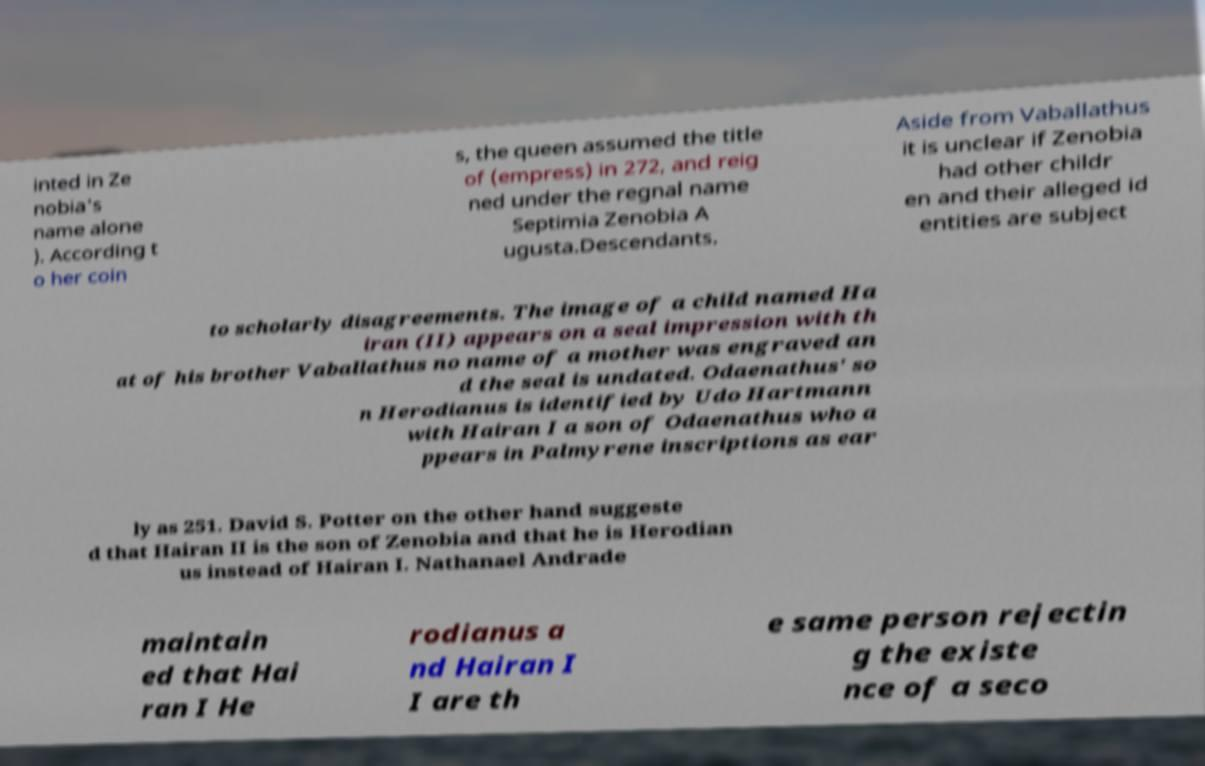There's text embedded in this image that I need extracted. Can you transcribe it verbatim? inted in Ze nobia's name alone ). According t o her coin s, the queen assumed the title of (empress) in 272, and reig ned under the regnal name Septimia Zenobia A ugusta.Descendants. Aside from Vaballathus it is unclear if Zenobia had other childr en and their alleged id entities are subject to scholarly disagreements. The image of a child named Ha iran (II) appears on a seal impression with th at of his brother Vaballathus no name of a mother was engraved an d the seal is undated. Odaenathus' so n Herodianus is identified by Udo Hartmann with Hairan I a son of Odaenathus who a ppears in Palmyrene inscriptions as ear ly as 251. David S. Potter on the other hand suggeste d that Hairan II is the son of Zenobia and that he is Herodian us instead of Hairan I. Nathanael Andrade maintain ed that Hai ran I He rodianus a nd Hairan I I are th e same person rejectin g the existe nce of a seco 